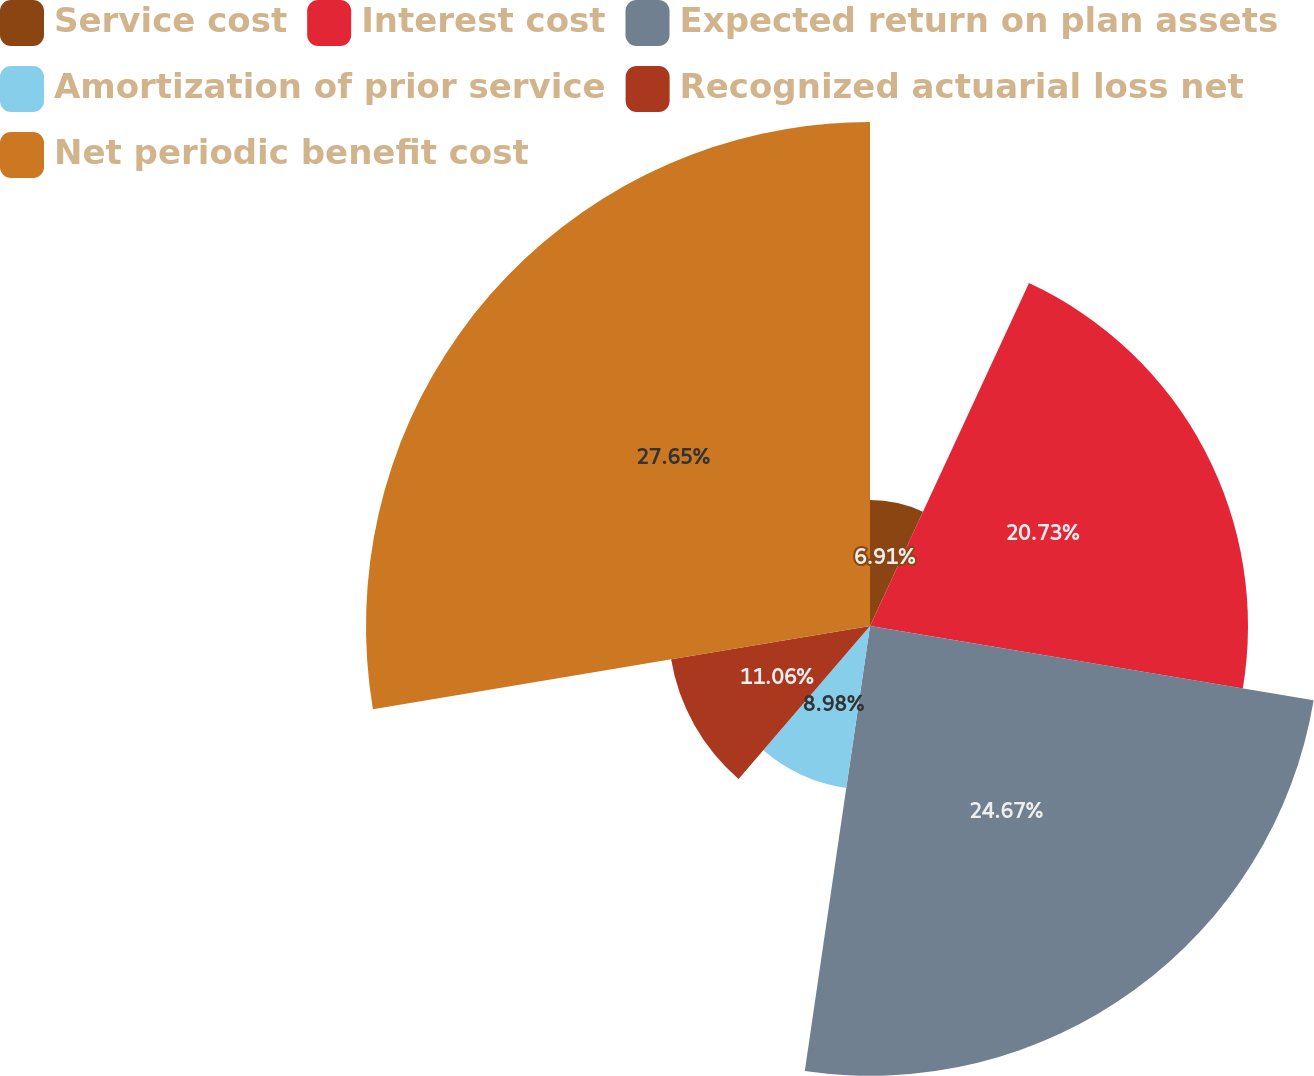Convert chart. <chart><loc_0><loc_0><loc_500><loc_500><pie_chart><fcel>Service cost<fcel>Interest cost<fcel>Expected return on plan assets<fcel>Amortization of prior service<fcel>Recognized actuarial loss net<fcel>Net periodic benefit cost<nl><fcel>6.91%<fcel>20.73%<fcel>24.67%<fcel>8.98%<fcel>11.06%<fcel>27.64%<nl></chart> 